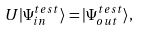Convert formula to latex. <formula><loc_0><loc_0><loc_500><loc_500>U | \Psi _ { i n } ^ { t e s t } \rangle = | \Psi _ { o u t } ^ { t e s t } \rangle ,</formula> 